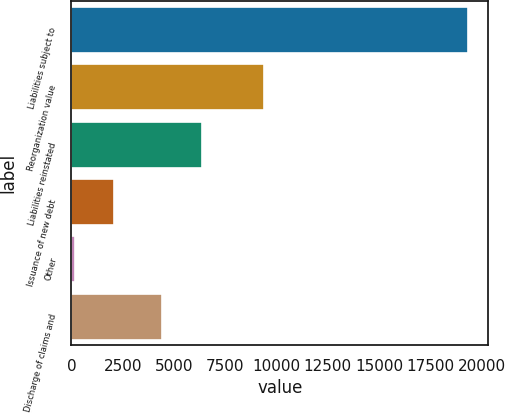Convert chart. <chart><loc_0><loc_0><loc_500><loc_500><bar_chart><fcel>Liabilities subject to<fcel>Reorganization value<fcel>Liabilities reinstated<fcel>Issuance of new debt<fcel>Other<fcel>Discharge of claims and<nl><fcel>19345<fcel>9400<fcel>6343.1<fcel>2073.1<fcel>154<fcel>4424<nl></chart> 